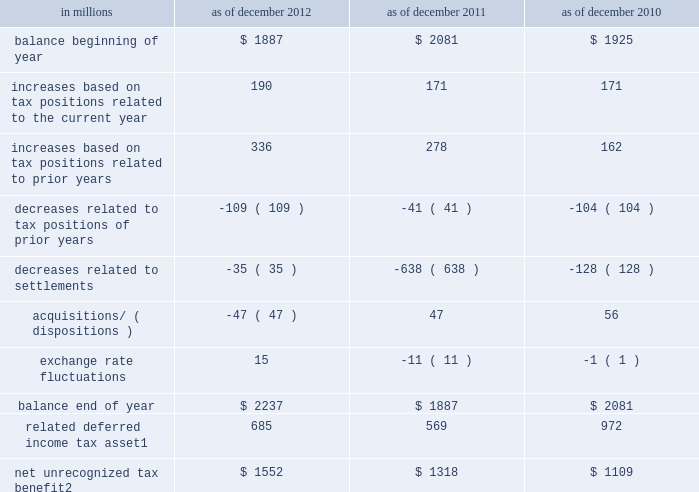Notes to consolidated financial statements the firm permanently reinvests eligible earnings of certain foreign subsidiaries and , accordingly , does not accrue any u.s .
Income taxes that would arise if such earnings were repatriated .
As of december 2012 and december 2011 , this policy resulted in an unrecognized net deferred tax liability of $ 3.75 billion and $ 3.32 billion , respectively , attributable to reinvested earnings of $ 21.69 billion and $ 20.63 billion , respectively .
Unrecognized tax benefits the firm recognizes tax positions in the financial statements only when it is more likely than not that the position will be sustained on examination by the relevant taxing authority based on the technical merits of the position .
A position that meets this standard is measured at the largest amount of benefit that will more likely than not be realized on settlement .
A liability is established for differences between positions taken in a tax return and amounts recognized in the financial statements .
As of december 2012 and december 2011 , the accrued liability for interest expense related to income tax matters and income tax penalties was $ 374 million and $ 233 million , respectively .
The firm recognized $ 95 million , $ 21 million and $ 28 million of interest and income tax penalties for the years ended december 2012 , december 2011 and december 2010 , respectively .
It is reasonably possible that unrecognized tax benefits could change significantly during the twelve months subsequent to december 2012 due to potential audit settlements , however , at this time it is not possible to estimate any potential change .
The table below presents the changes in the liability for unrecognized tax benefits .
This liability is included in 201cother liabilities and accrued expenses . 201d see note 17 for further information. .
Related deferred income tax asset 1 685 569 972 net unrecognized tax benefit 2 $ 1552 $ 1318 $ 1109 1 .
Included in 201cother assets . 201d see note 12 .
If recognized , the net tax benefit would reduce the firm 2019s effective income tax rate .
194 goldman sachs 2012 annual report .
What is the percentage change in the net unrecognized tax benefit in 2012 compare to 2011? 
Computations: ((1552 - 1318) / 1318)
Answer: 0.17754. 